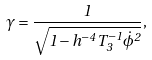Convert formula to latex. <formula><loc_0><loc_0><loc_500><loc_500>\gamma = \frac { 1 } { \sqrt { 1 - h ^ { - 4 } T _ { 3 } ^ { - 1 } \dot { \phi } ^ { 2 } } } ,</formula> 